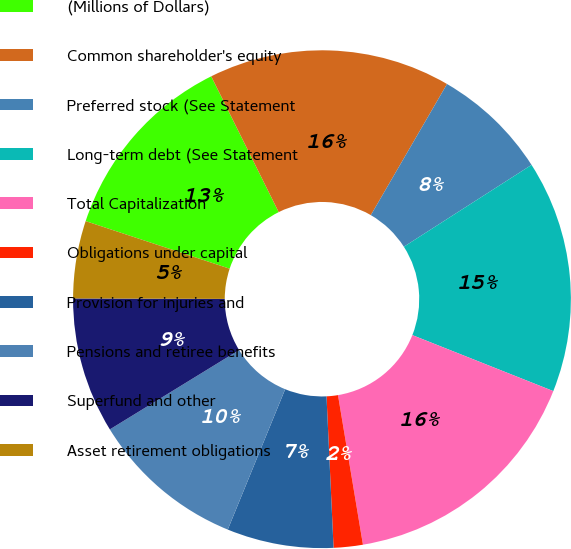Convert chart. <chart><loc_0><loc_0><loc_500><loc_500><pie_chart><fcel>(Millions of Dollars)<fcel>Common shareholder's equity<fcel>Preferred stock (See Statement<fcel>Long-term debt (See Statement<fcel>Total Capitalization<fcel>Obligations under capital<fcel>Provision for injuries and<fcel>Pensions and retiree benefits<fcel>Superfund and other<fcel>Asset retirement obligations<nl><fcel>12.58%<fcel>15.72%<fcel>7.55%<fcel>15.09%<fcel>16.35%<fcel>1.89%<fcel>6.92%<fcel>10.06%<fcel>8.81%<fcel>5.03%<nl></chart> 